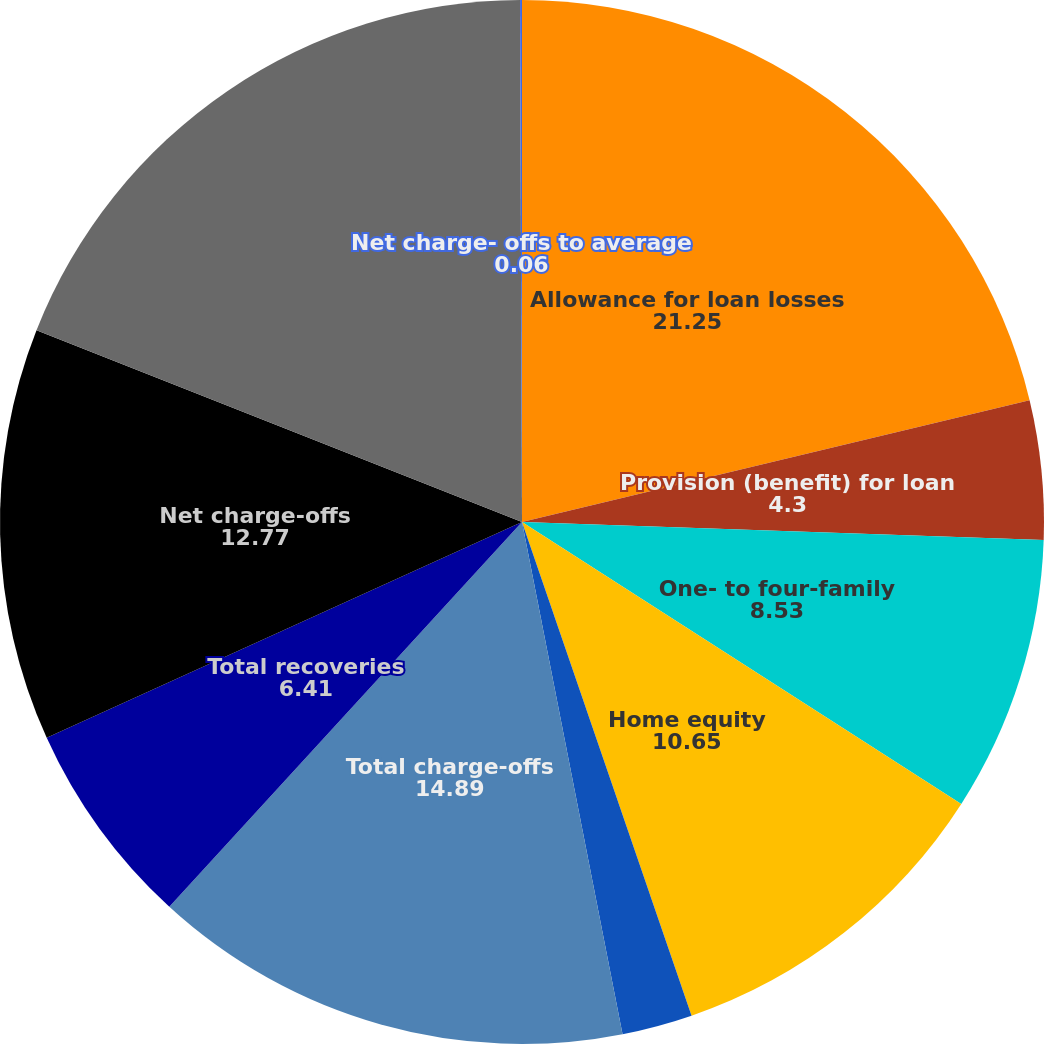Convert chart to OTSL. <chart><loc_0><loc_0><loc_500><loc_500><pie_chart><fcel>Allowance for loan losses<fcel>Provision (benefit) for loan<fcel>One- to four-family<fcel>Home equity<fcel>Consumer and other<fcel>Total charge-offs<fcel>Total recoveries<fcel>Net charge-offs<fcel>Allowance for loan losses end<fcel>Net charge- offs to average<nl><fcel>21.25%<fcel>4.3%<fcel>8.53%<fcel>10.65%<fcel>2.18%<fcel>14.89%<fcel>6.41%<fcel>12.77%<fcel>18.95%<fcel>0.06%<nl></chart> 